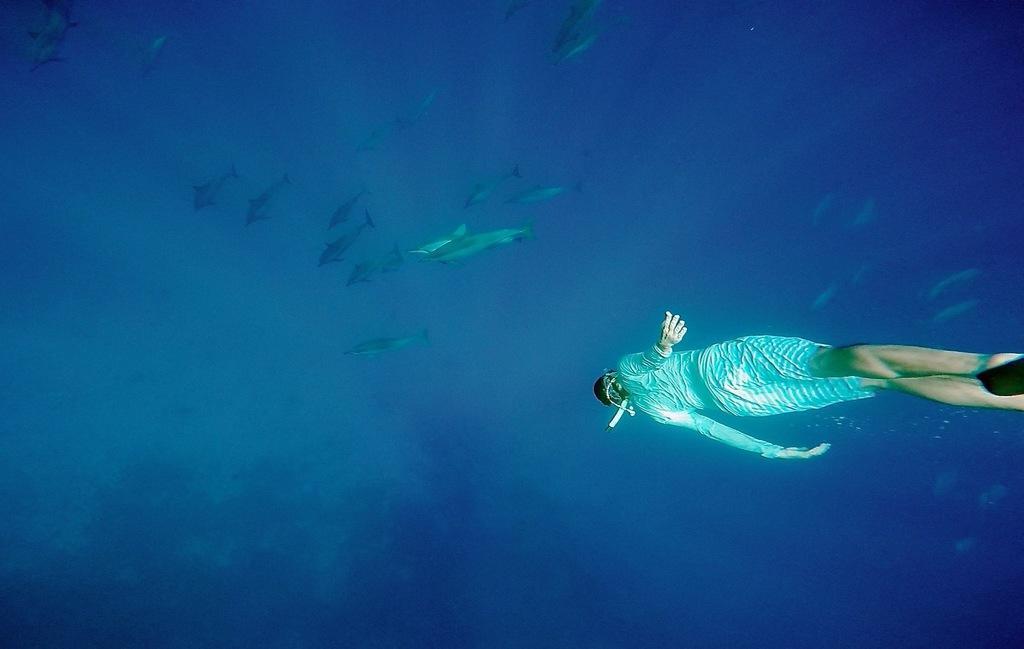In one or two sentences, can you explain what this image depicts? In this image we can see a person swimming underwater and there are many fishes in front oh him. 